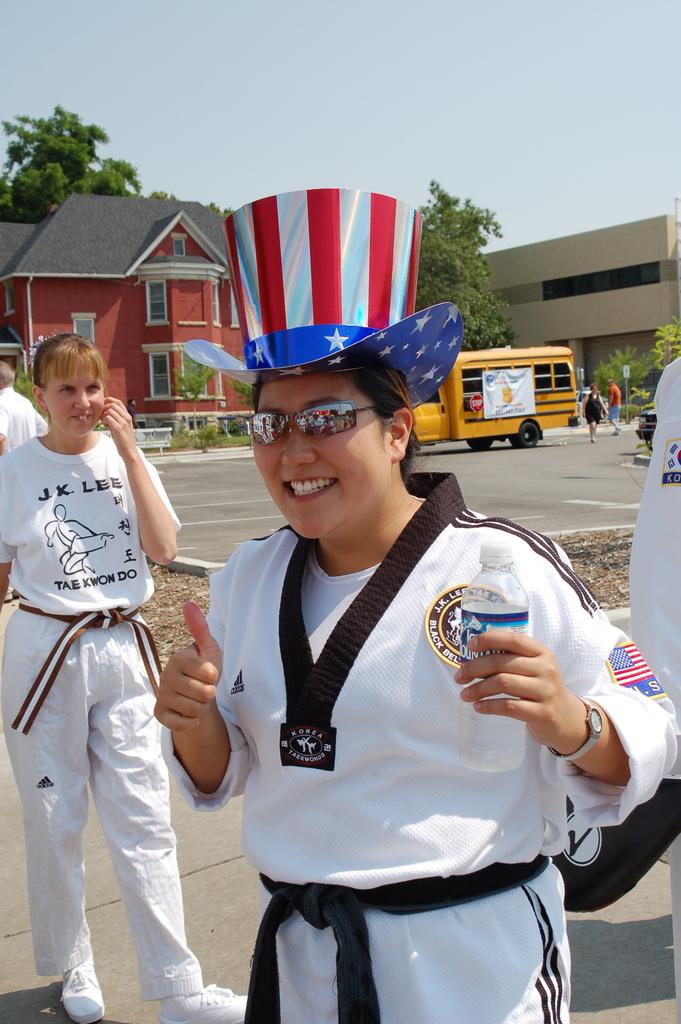What kind of martial arts do they practice?
Provide a short and direct response. Tae kwon do. What two initials are on the person on the left shirt?
Your answer should be compact. J.k. 